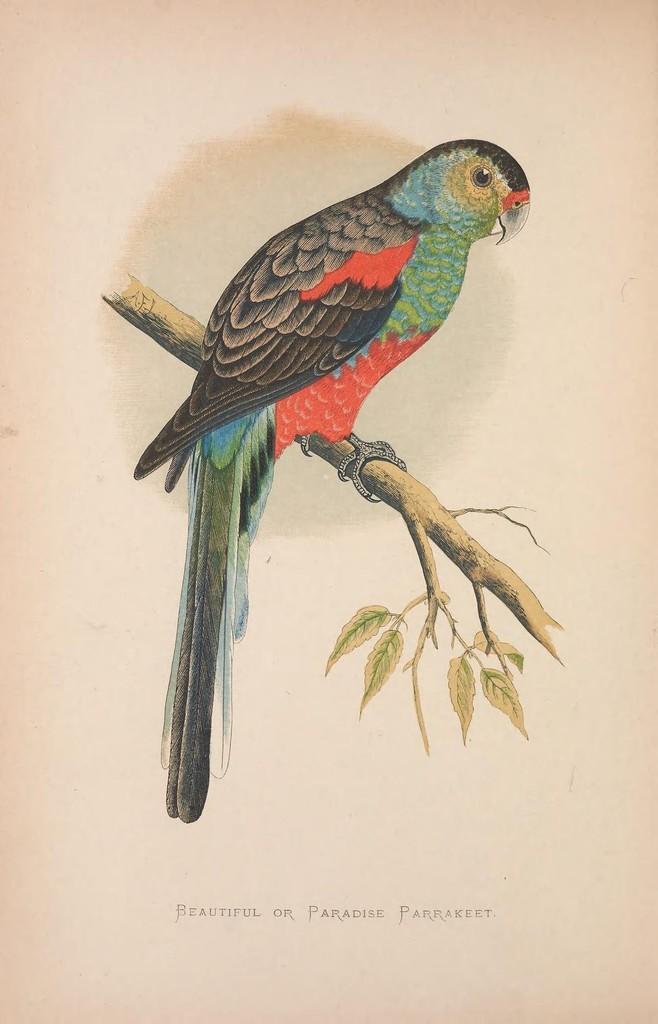Please provide a concise description of this image. In this picture I can see a printed image of a bird on the tree branch and I can see text at the bottom of the image. 